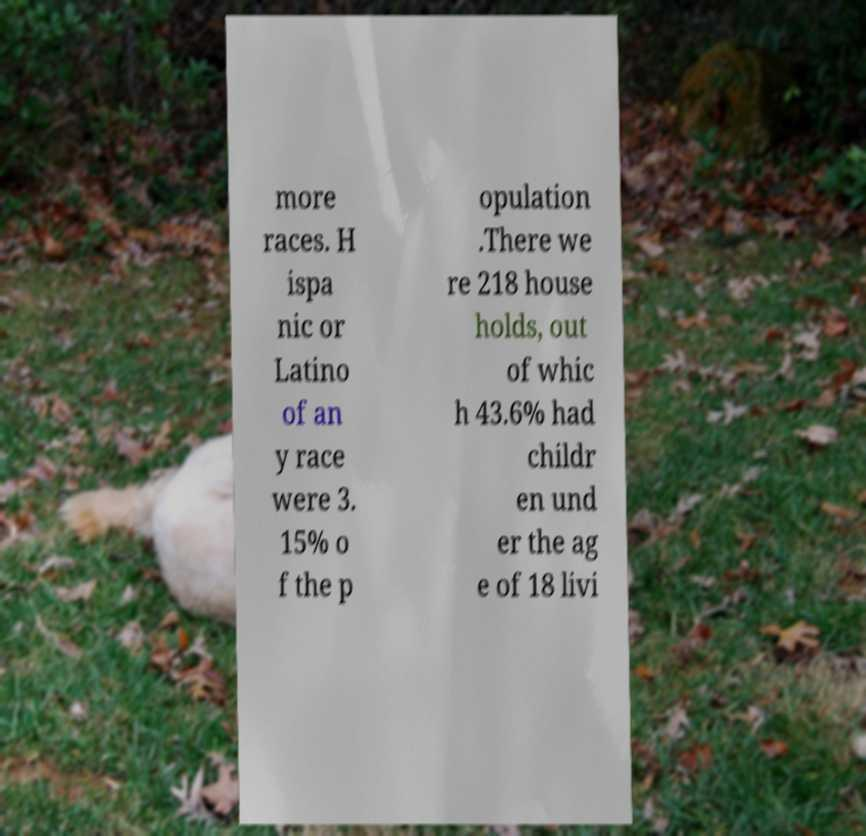For documentation purposes, I need the text within this image transcribed. Could you provide that? more races. H ispa nic or Latino of an y race were 3. 15% o f the p opulation .There we re 218 house holds, out of whic h 43.6% had childr en und er the ag e of 18 livi 